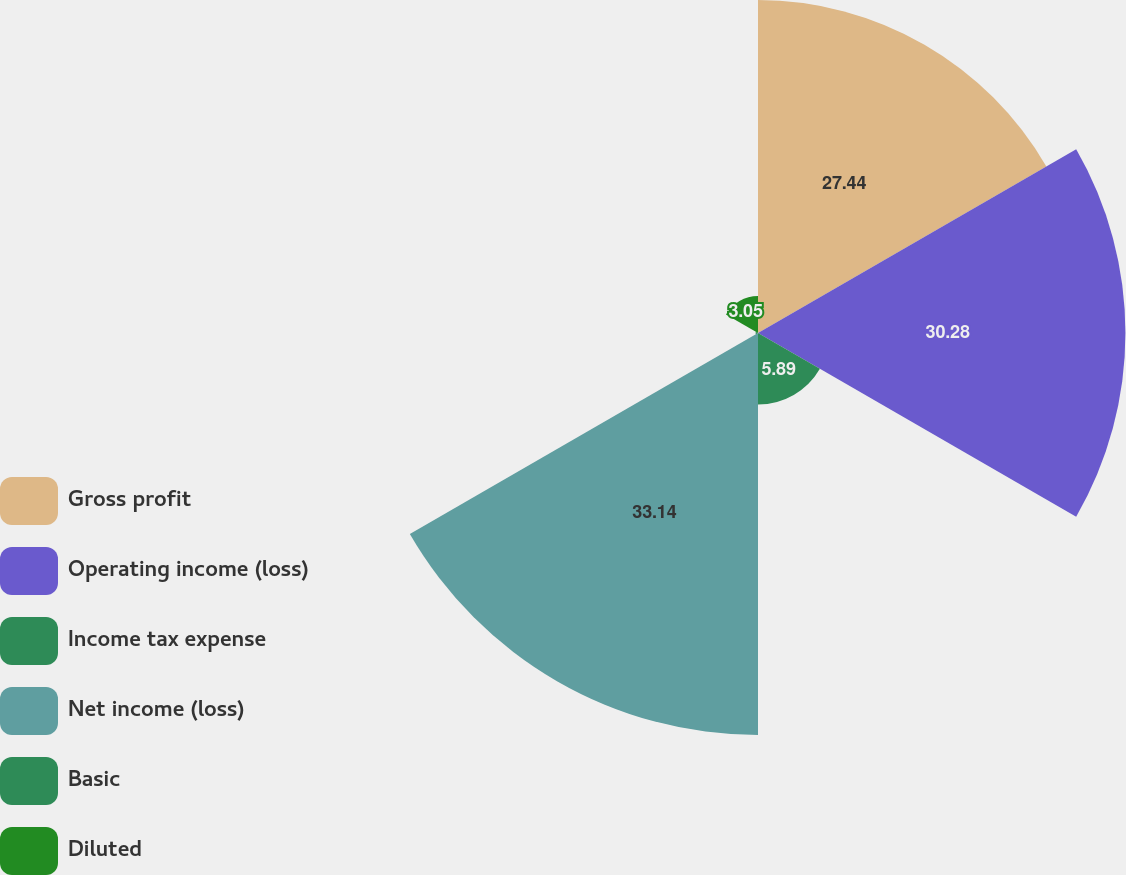<chart> <loc_0><loc_0><loc_500><loc_500><pie_chart><fcel>Gross profit<fcel>Operating income (loss)<fcel>Income tax expense<fcel>Net income (loss)<fcel>Basic<fcel>Diluted<nl><fcel>27.44%<fcel>30.28%<fcel>5.89%<fcel>33.13%<fcel>0.2%<fcel>3.05%<nl></chart> 